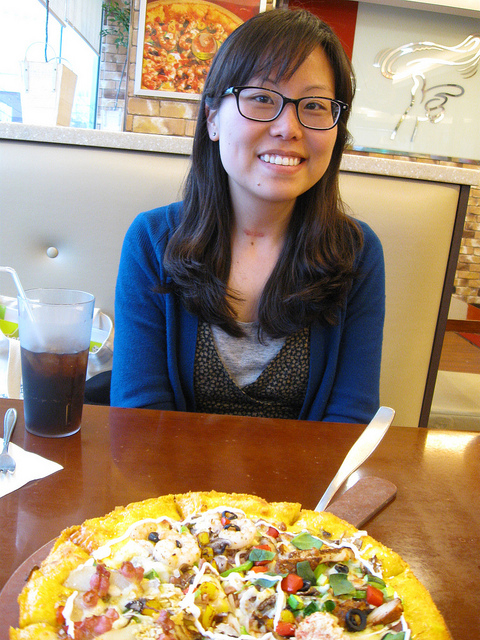Can you describe the person's attire? Certainly! The individual in the image is wearing a blue cardigan over a gray top. They are seated comfortably at a table, with a friendly smile that suggests they are enjoying their time, perhaps out at a pizzeria or a casual dining restaurant. Does the environment tell us anything about the place where the photo was taken? While the specific location isn't clear, the environment suggests a warm and welcoming indoor setting, likely a dining establishment. There's artwork on the walls, which adds to the cozy ambiance, and a neatly arranged table setting that implies good service and an enjoyable dining experience. 